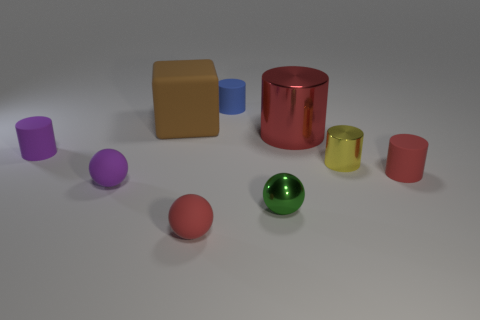How many metallic cylinders have the same size as the cube?
Ensure brevity in your answer.  1. Do the purple object that is to the right of the small purple cylinder and the large cylinder have the same material?
Your answer should be very brief. No. Is there a tiny gray matte cylinder?
Keep it short and to the point. No. There is a purple ball that is made of the same material as the brown block; what is its size?
Make the answer very short. Small. Are there any small matte cylinders of the same color as the big shiny cylinder?
Your answer should be compact. Yes. Does the tiny matte object that is on the left side of the small purple sphere have the same color as the tiny metal thing that is in front of the purple ball?
Give a very brief answer. No. The rubber sphere that is the same color as the large cylinder is what size?
Your response must be concise. Small. Is there a big cylinder that has the same material as the brown thing?
Give a very brief answer. No. What color is the metal sphere?
Give a very brief answer. Green. There is a shiny cylinder that is behind the rubber cylinder that is to the left of the small red object that is in front of the green shiny object; how big is it?
Ensure brevity in your answer.  Large. 